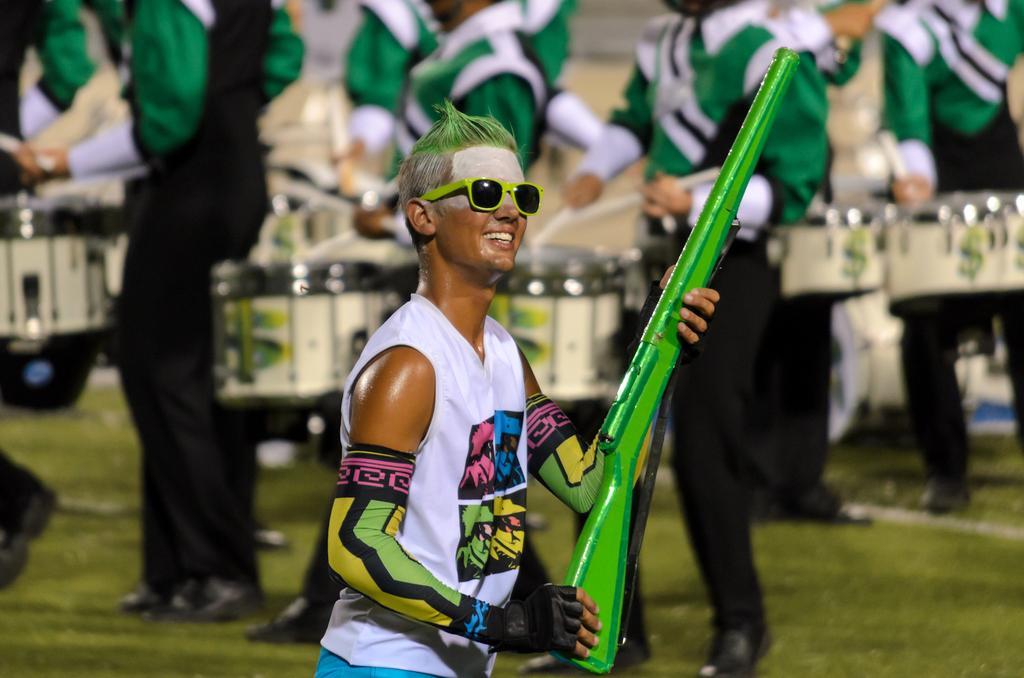In one or two sentences, can you explain what this image depicts? This image consists of a man holding a gun in green color. He is wearing shades. At the bottom, there is green grass. In the background, there are many people playing drums. They all are wearing green shirts. 